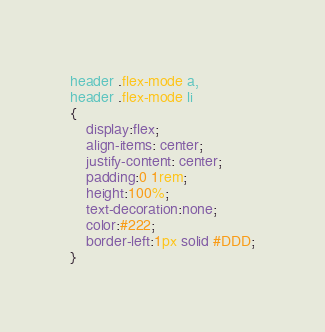Convert code to text. <code><loc_0><loc_0><loc_500><loc_500><_CSS_>header .flex-mode a,
header .flex-mode li
{
    display:flex;
    align-items: center;
    justify-content: center;
    padding:0 1rem;
    height:100%;
    text-decoration:none;
    color:#222;
    border-left:1px solid #DDD;
}</code> 